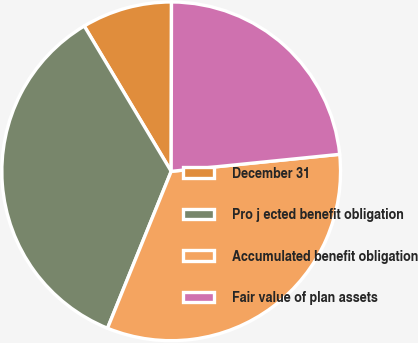Convert chart to OTSL. <chart><loc_0><loc_0><loc_500><loc_500><pie_chart><fcel>December 31<fcel>Pro j ected benefit obligation<fcel>Accumulated benefit obligation<fcel>Fair value of plan assets<nl><fcel>8.61%<fcel>35.28%<fcel>32.74%<fcel>23.37%<nl></chart> 